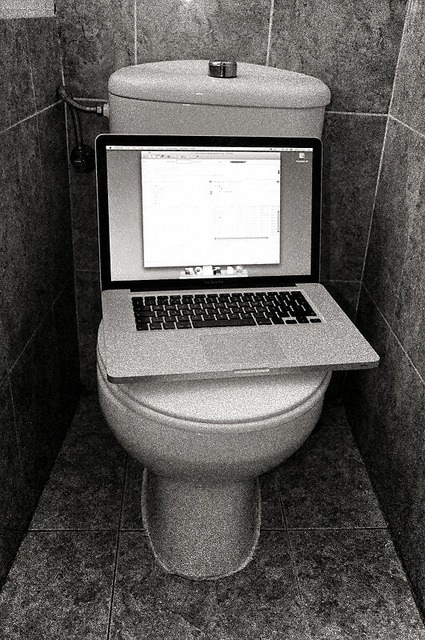Describe the objects in this image and their specific colors. I can see laptop in gray, white, darkgray, and black tones and toilet in gray, darkgray, lightgray, and black tones in this image. 